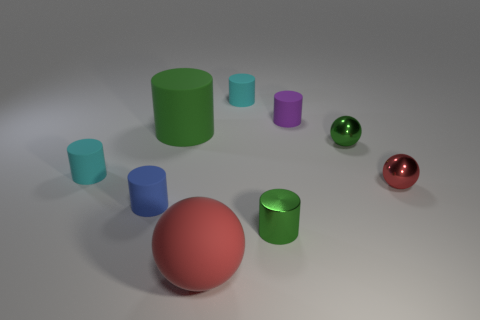How many other objects are the same material as the purple thing?
Keep it short and to the point. 5. Does the green thing in front of the red shiny ball have the same material as the tiny red thing that is behind the green metallic cylinder?
Your answer should be compact. Yes. The green object that is made of the same material as the big red object is what shape?
Give a very brief answer. Cylinder. Is there any other thing that has the same color as the metal cylinder?
Provide a short and direct response. Yes. How many green cylinders are there?
Make the answer very short. 2. There is a object that is both in front of the blue matte cylinder and behind the matte ball; what is its shape?
Your answer should be compact. Cylinder. There is a red object right of the small shiny ball behind the rubber thing left of the tiny blue cylinder; what is its shape?
Your answer should be compact. Sphere. There is a sphere that is both in front of the small green sphere and behind the rubber ball; what is its material?
Offer a very short reply. Metal. How many metallic balls are the same size as the blue cylinder?
Keep it short and to the point. 2. What number of matte objects are cyan cylinders or tiny balls?
Provide a succinct answer. 2. 